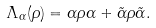Convert formula to latex. <formula><loc_0><loc_0><loc_500><loc_500>\Lambda _ { \alpha } ( \rho ) = \alpha \rho \alpha + \tilde { \alpha } \rho \tilde { \alpha } .</formula> 